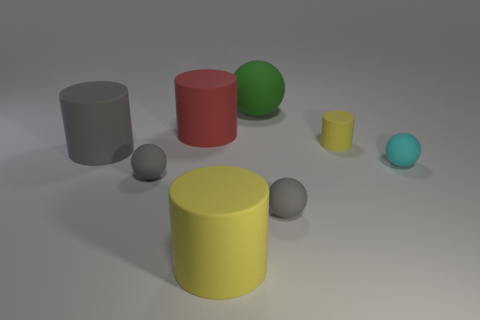There is a small gray object on the left side of the green matte ball; does it have the same shape as the big gray rubber object?
Provide a short and direct response. No. How many spheres are both on the right side of the large red cylinder and in front of the red thing?
Make the answer very short. 2. How many other objects are there of the same size as the gray cylinder?
Ensure brevity in your answer.  3. Are there an equal number of yellow things that are behind the tiny yellow object and big objects?
Your response must be concise. No. Does the tiny rubber thing to the left of the big matte ball have the same color as the ball behind the cyan object?
Give a very brief answer. No. There is a small sphere that is to the right of the large red thing and on the left side of the tiny cyan matte thing; what material is it?
Ensure brevity in your answer.  Rubber. What color is the large matte sphere?
Offer a terse response. Green. How many other objects are the same shape as the large gray thing?
Offer a very short reply. 3. Are there an equal number of big yellow matte cylinders behind the cyan rubber thing and rubber spheres that are in front of the large yellow matte object?
Provide a succinct answer. Yes. What is the material of the big sphere?
Offer a terse response. Rubber. 